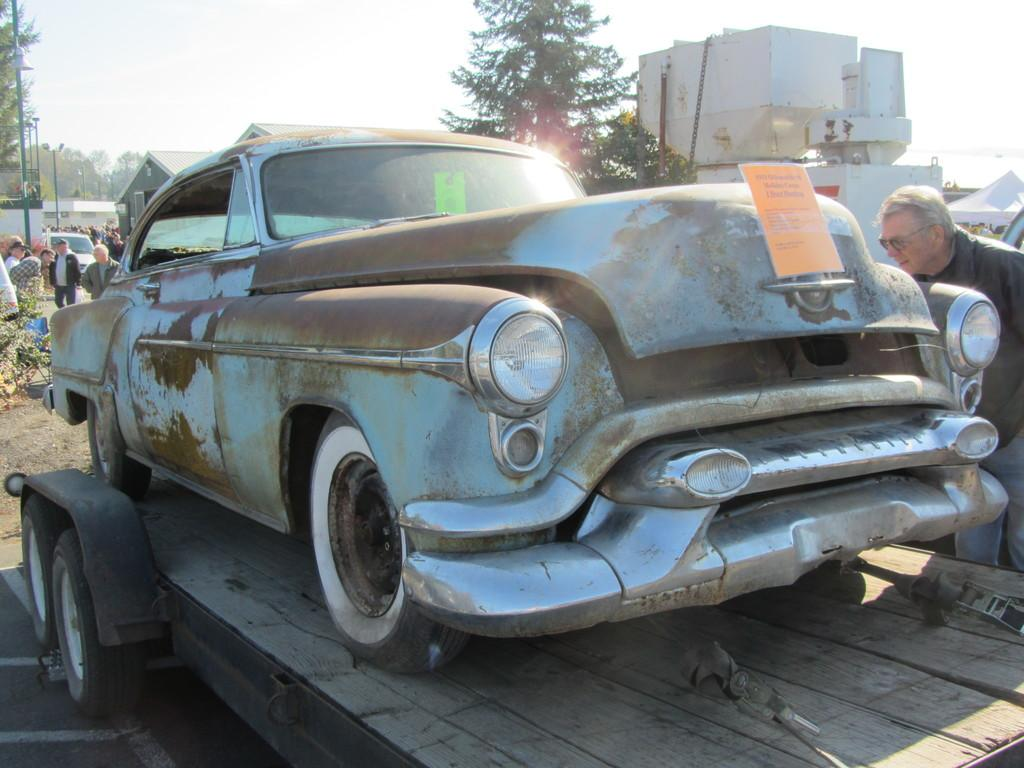What is the main object in the image? There is a cart in the image. What is on the cart? There is a car on the cart. What can be seen in the background of the image? There are people, trees, buildings, and the sky visible in the background of the image. What type of ring can be seen on the car's tire in the image? There is no ring present on the car's tire in the image. How does the car stop in the image? The image does not show the car stopping or any indication of how it stops. 